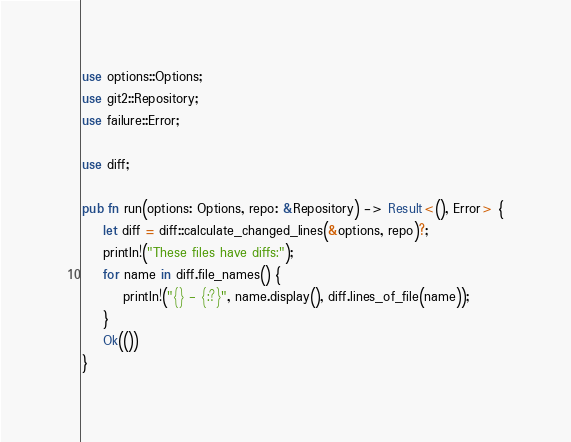<code> <loc_0><loc_0><loc_500><loc_500><_Rust_>use options::Options;
use git2::Repository;
use failure::Error;

use diff;

pub fn run(options: Options, repo: &Repository) -> Result<(), Error> {
    let diff = diff::calculate_changed_lines(&options, repo)?;
    println!("These files have diffs:");
    for name in diff.file_names() {
        println!("{} - {:?}", name.display(), diff.lines_of_file(name));
    }
    Ok(())
}
</code> 